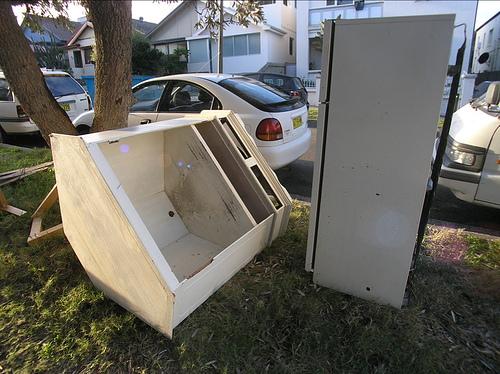How many white cars are shown?
Concise answer only. 3. Is someone going to pick up this fridge?
Answer briefly. Yes. Why are these household objects sitting at the side of the road?
Short answer required. Garbage. What color is the car?
Give a very brief answer. White. 